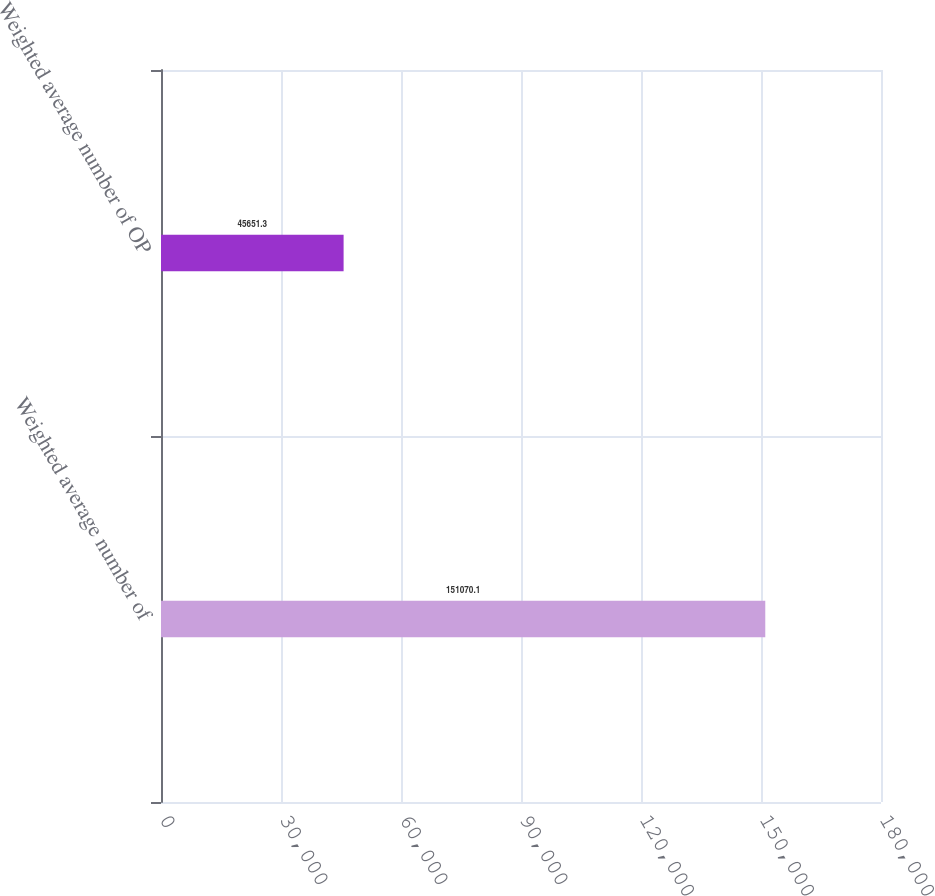Convert chart. <chart><loc_0><loc_0><loc_500><loc_500><bar_chart><fcel>Weighted average number of<fcel>Weighted average number of OP<nl><fcel>151070<fcel>45651.3<nl></chart> 